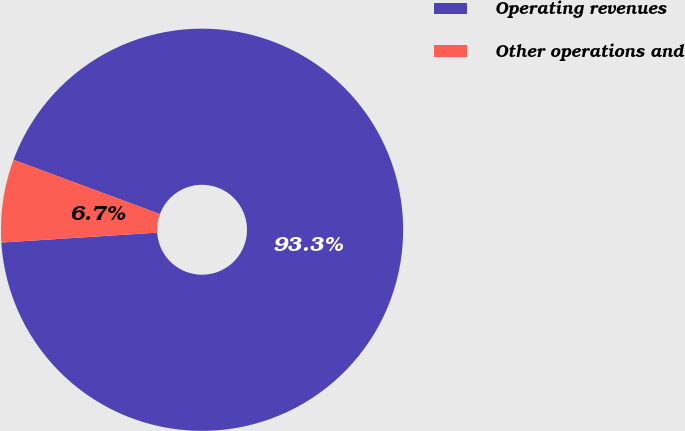Convert chart. <chart><loc_0><loc_0><loc_500><loc_500><pie_chart><fcel>Operating revenues<fcel>Other operations and<nl><fcel>93.33%<fcel>6.67%<nl></chart> 